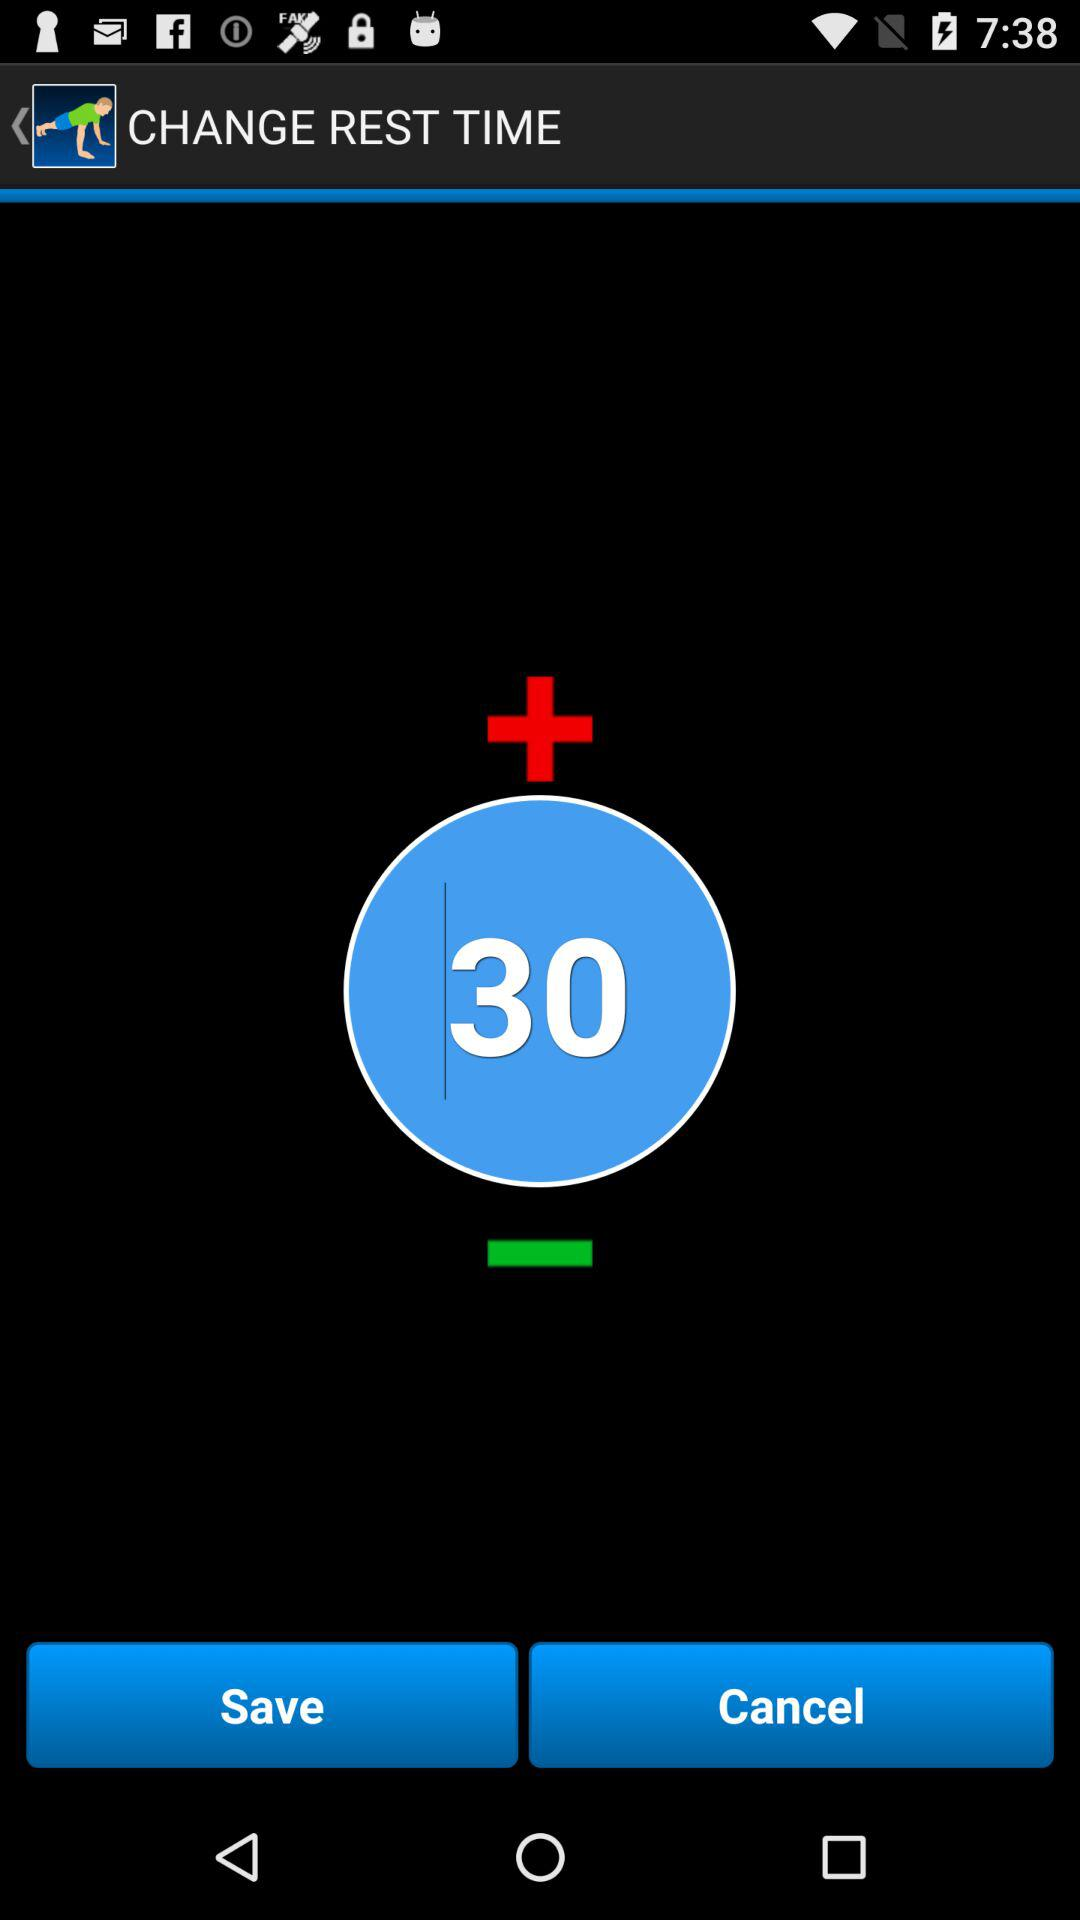What is the set rest duration? The set rest duration is 30. 